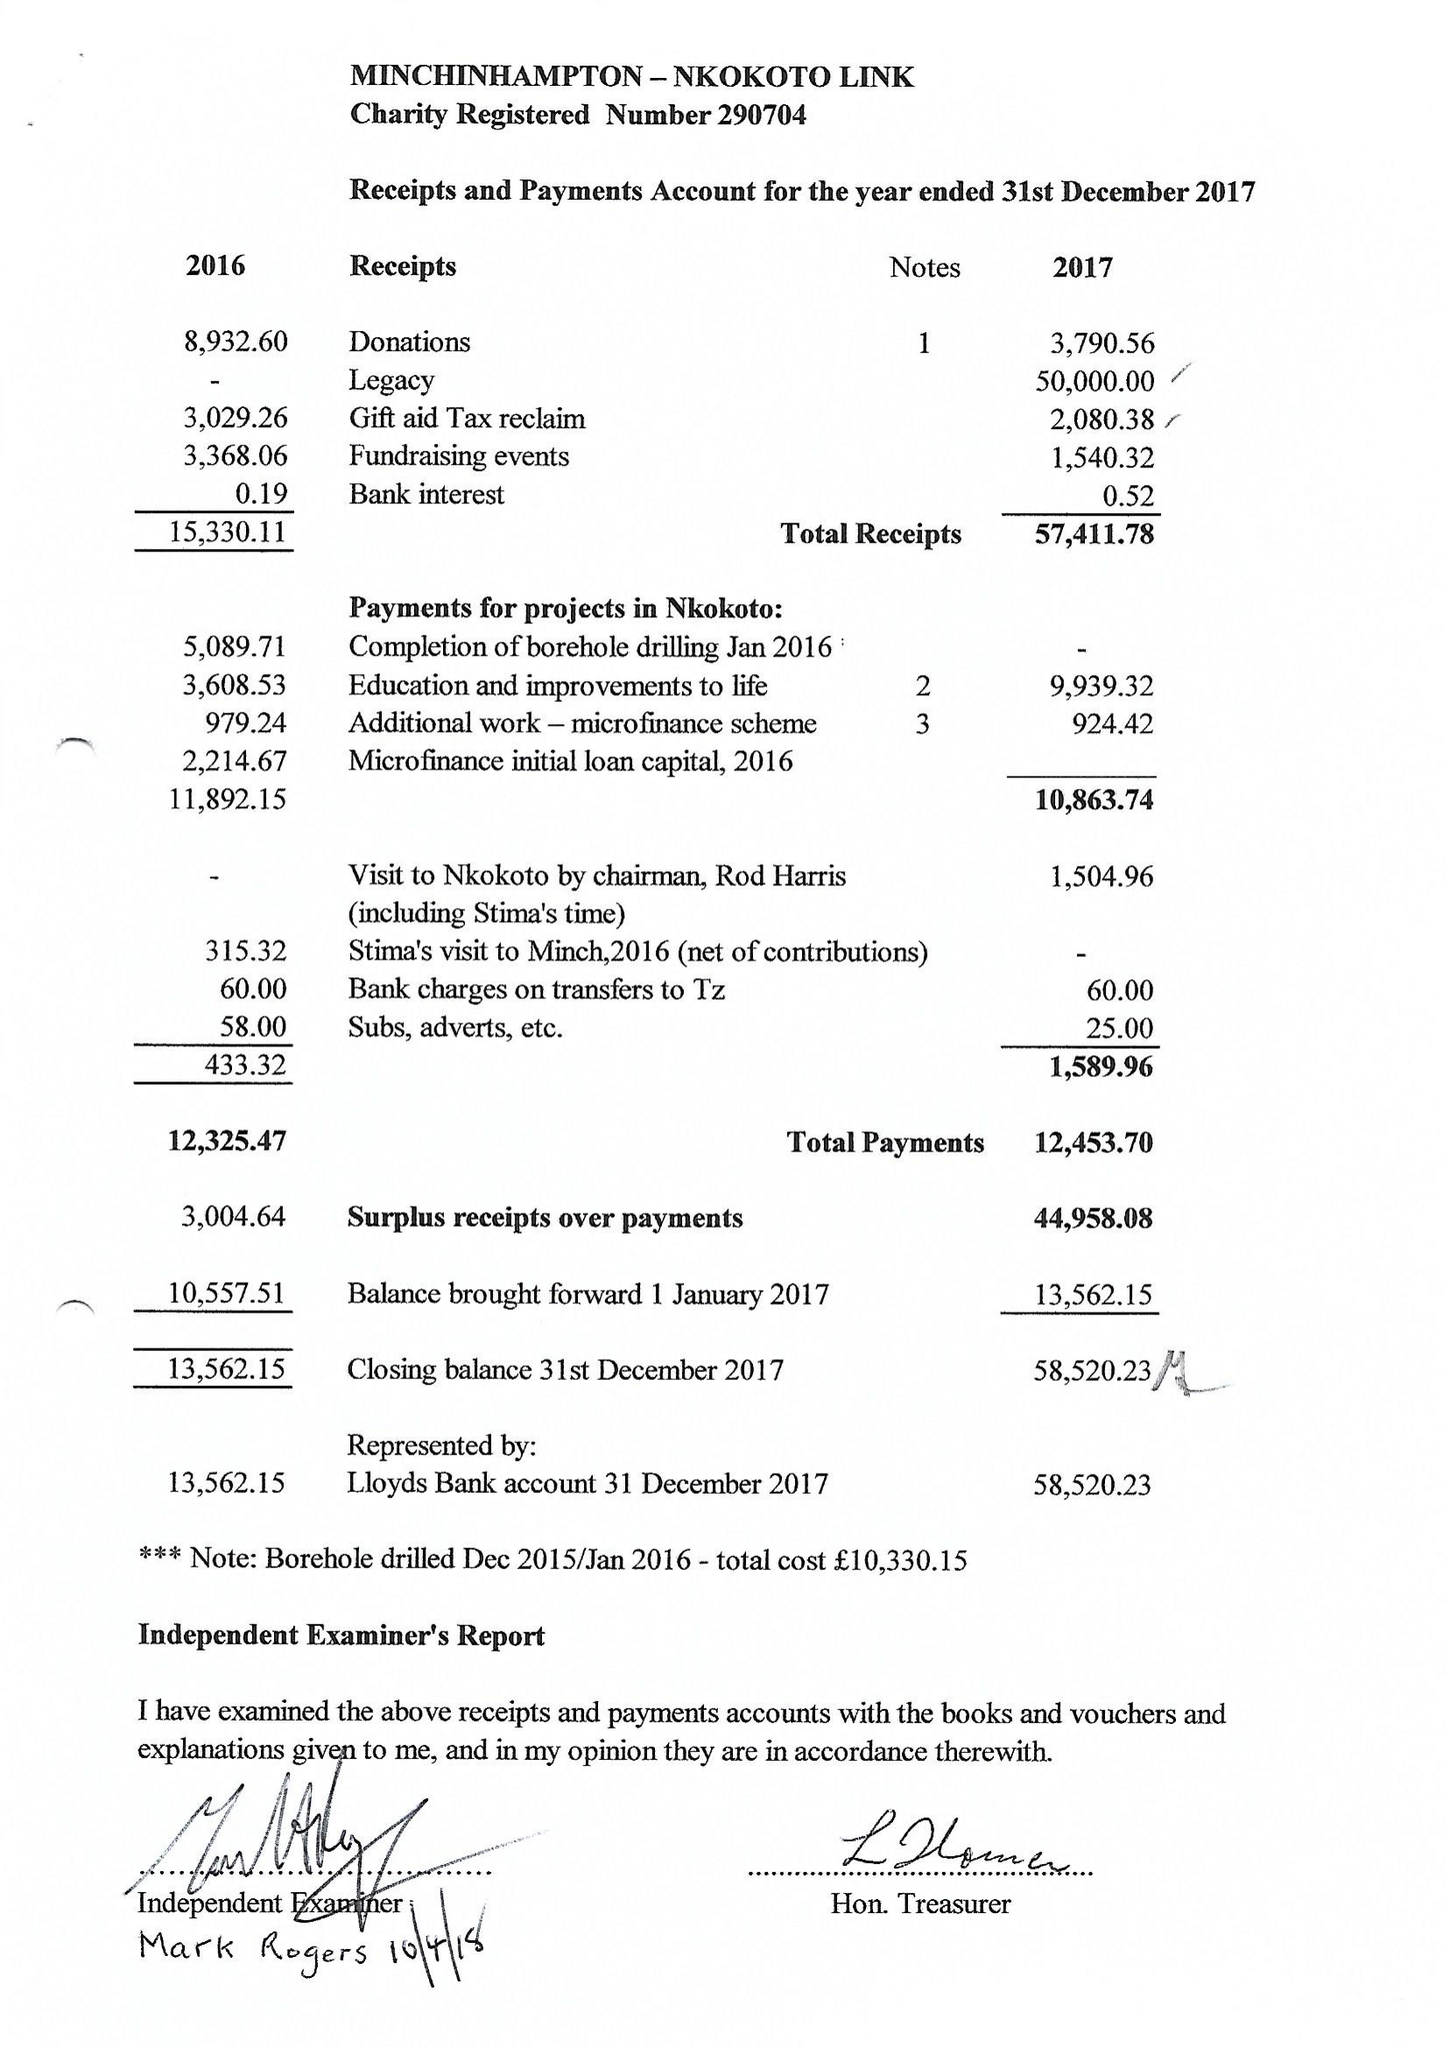What is the value for the report_date?
Answer the question using a single word or phrase. 2017-12-31 